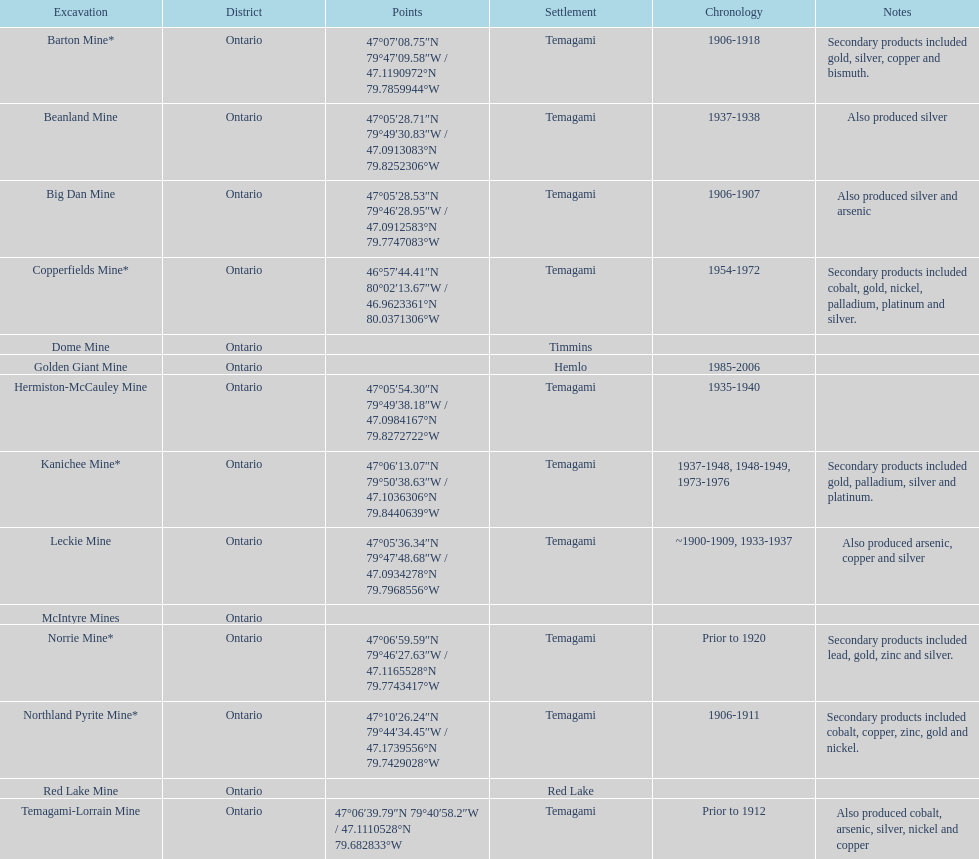Can you give me this table as a dict? {'header': ['Excavation', 'District', 'Points', 'Settlement', 'Chronology', 'Notes'], 'rows': [['Barton Mine*', 'Ontario', '47°07′08.75″N 79°47′09.58″W\ufeff / \ufeff47.1190972°N 79.7859944°W', 'Temagami', '1906-1918', 'Secondary products included gold, silver, copper and bismuth.'], ['Beanland Mine', 'Ontario', '47°05′28.71″N 79°49′30.83″W\ufeff / \ufeff47.0913083°N 79.8252306°W', 'Temagami', '1937-1938', 'Also produced silver'], ['Big Dan Mine', 'Ontario', '47°05′28.53″N 79°46′28.95″W\ufeff / \ufeff47.0912583°N 79.7747083°W', 'Temagami', '1906-1907', 'Also produced silver and arsenic'], ['Copperfields Mine*', 'Ontario', '46°57′44.41″N 80°02′13.67″W\ufeff / \ufeff46.9623361°N 80.0371306°W', 'Temagami', '1954-1972', 'Secondary products included cobalt, gold, nickel, palladium, platinum and silver.'], ['Dome Mine', 'Ontario', '', 'Timmins', '', ''], ['Golden Giant Mine', 'Ontario', '', 'Hemlo', '1985-2006', ''], ['Hermiston-McCauley Mine', 'Ontario', '47°05′54.30″N 79°49′38.18″W\ufeff / \ufeff47.0984167°N 79.8272722°W', 'Temagami', '1935-1940', ''], ['Kanichee Mine*', 'Ontario', '47°06′13.07″N 79°50′38.63″W\ufeff / \ufeff47.1036306°N 79.8440639°W', 'Temagami', '1937-1948, 1948-1949, 1973-1976', 'Secondary products included gold, palladium, silver and platinum.'], ['Leckie Mine', 'Ontario', '47°05′36.34″N 79°47′48.68″W\ufeff / \ufeff47.0934278°N 79.7968556°W', 'Temagami', '~1900-1909, 1933-1937', 'Also produced arsenic, copper and silver'], ['McIntyre Mines', 'Ontario', '', '', '', ''], ['Norrie Mine*', 'Ontario', '47°06′59.59″N 79°46′27.63″W\ufeff / \ufeff47.1165528°N 79.7743417°W', 'Temagami', 'Prior to 1920', 'Secondary products included lead, gold, zinc and silver.'], ['Northland Pyrite Mine*', 'Ontario', '47°10′26.24″N 79°44′34.45″W\ufeff / \ufeff47.1739556°N 79.7429028°W', 'Temagami', '1906-1911', 'Secondary products included cobalt, copper, zinc, gold and nickel.'], ['Red Lake Mine', 'Ontario', '', 'Red Lake', '', ''], ['Temagami-Lorrain Mine', 'Ontario', '47°06′39.79″N 79°40′58.2″W\ufeff / \ufeff47.1110528°N 79.682833°W', 'Temagami', 'Prior to 1912', 'Also produced cobalt, arsenic, silver, nickel and copper']]} How many instances of temagami can be found on the list? 10. 